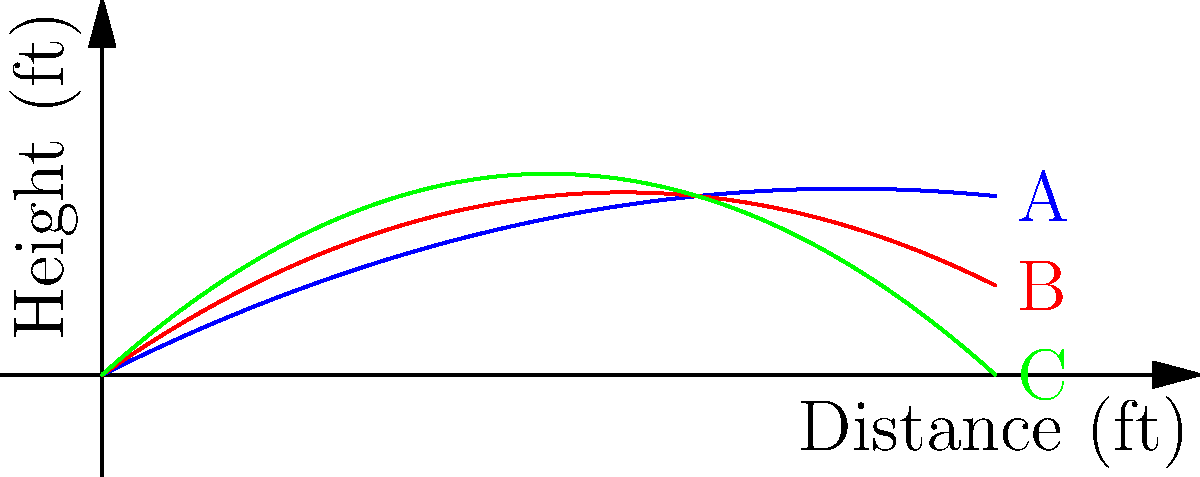As a star pitcher, you're analyzing pitch trajectories. The graph shows three different pitch trajectories (A, B, and C) plotted as height vs. distance from the pitcher. Which trajectory is most likely to represent a curveball? To determine which trajectory is most likely to represent a curveball, we need to consider the characteristics of different pitch types:

1. Fastballs typically have a relatively straight trajectory with less drop.
2. Curveballs have a more pronounced downward break, especially towards the end of their flight.
3. Sliders usually have a more lateral movement with less vertical drop than curveballs.

Analyzing the trajectories:

A (Blue): This trajectory has the least curvature and maintains height longer, typical of a fastball.
B (Red): This trajectory shows moderate curvature, possibly representing a slider.
C (Green): This trajectory has the most pronounced downward break, especially towards the end.

The curveball is characterized by its significant downward break, which is most evident in trajectory C (Green). This pitch starts higher and drops more sharply than the others, consistent with the spinning motion imparted on a curveball.

Therefore, trajectory C is most likely to represent a curveball.
Answer: C 